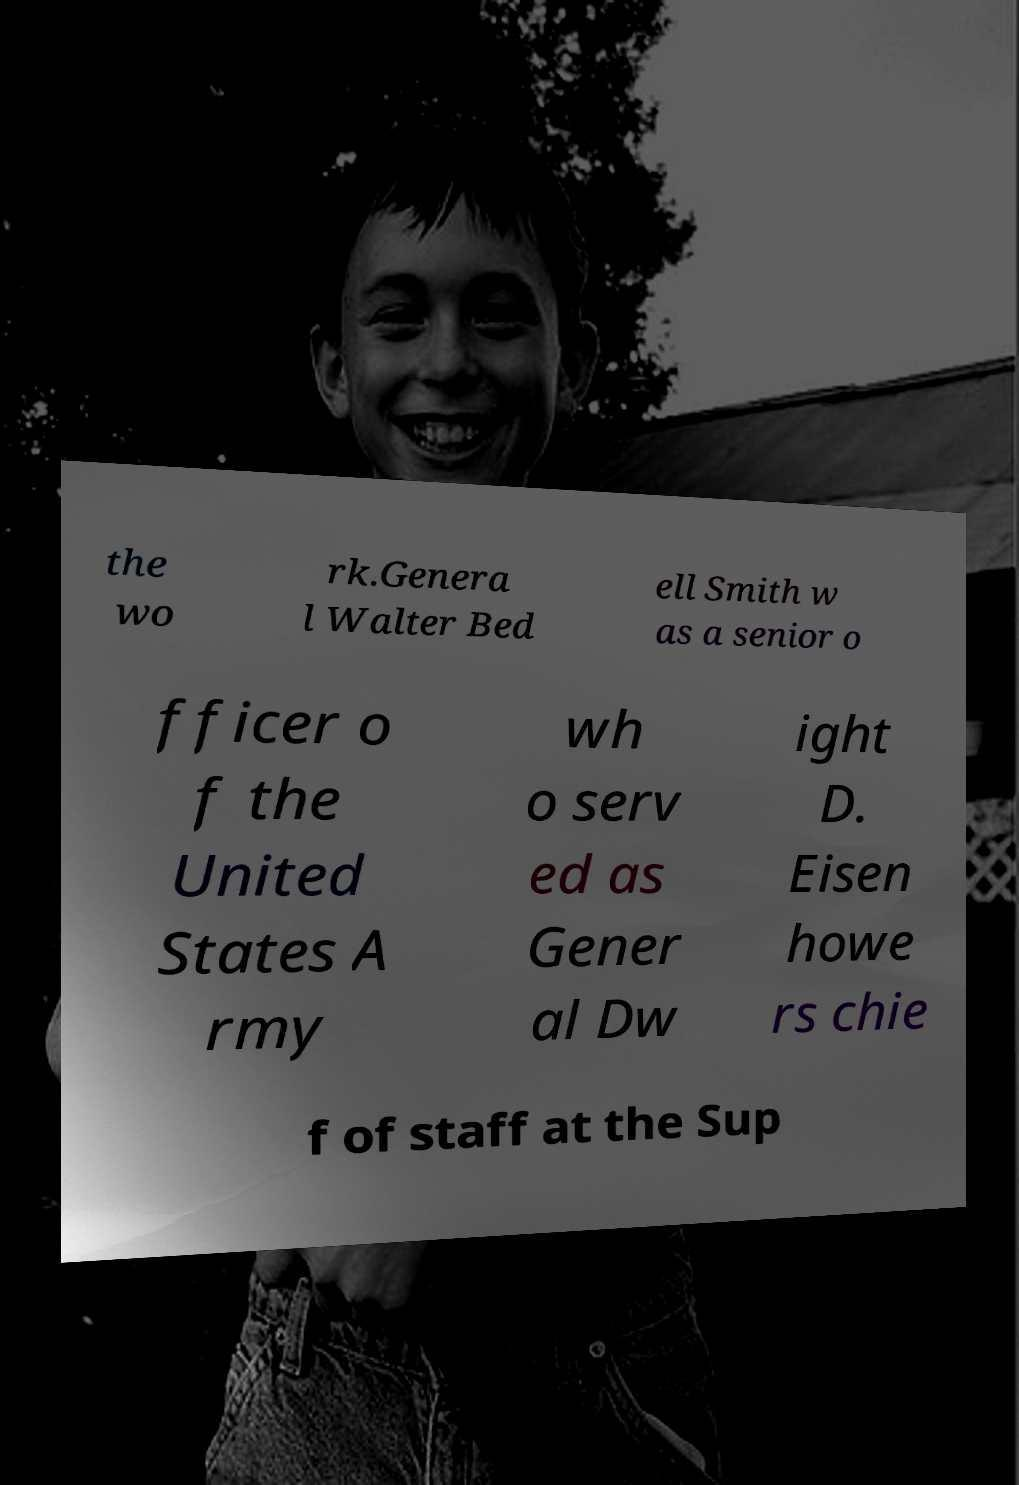Can you read and provide the text displayed in the image?This photo seems to have some interesting text. Can you extract and type it out for me? the wo rk.Genera l Walter Bed ell Smith w as a senior o fficer o f the United States A rmy wh o serv ed as Gener al Dw ight D. Eisen howe rs chie f of staff at the Sup 